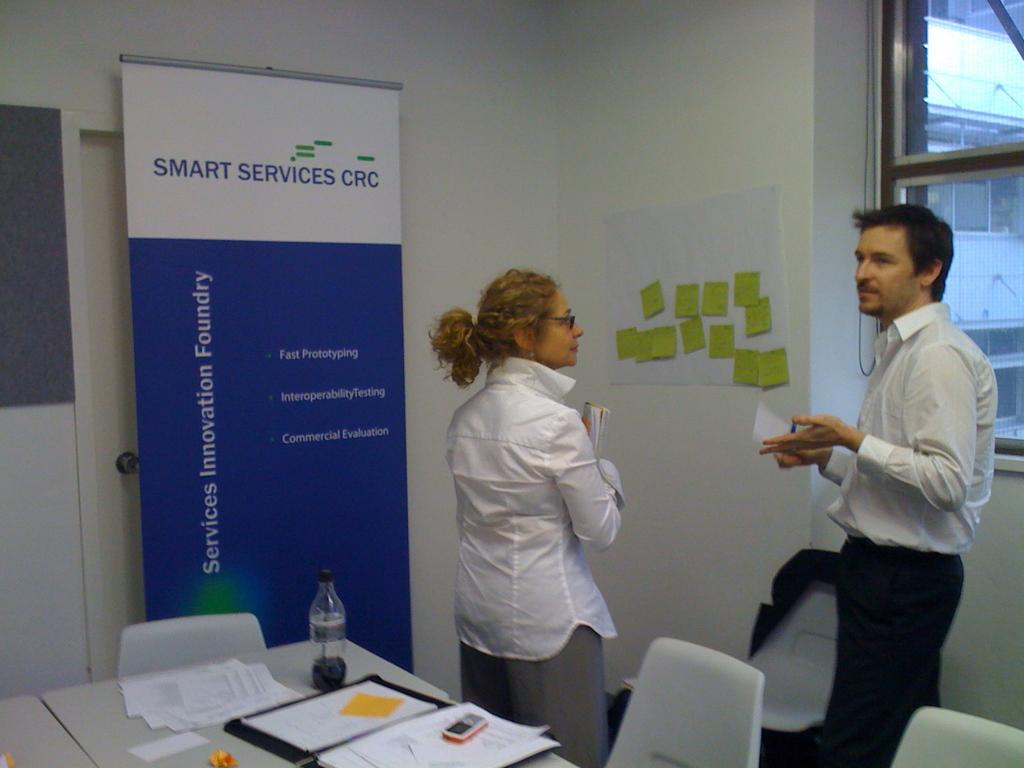<image>
Create a compact narrative representing the image presented. A man an a woman stand in front of a board titled Smart Services. 